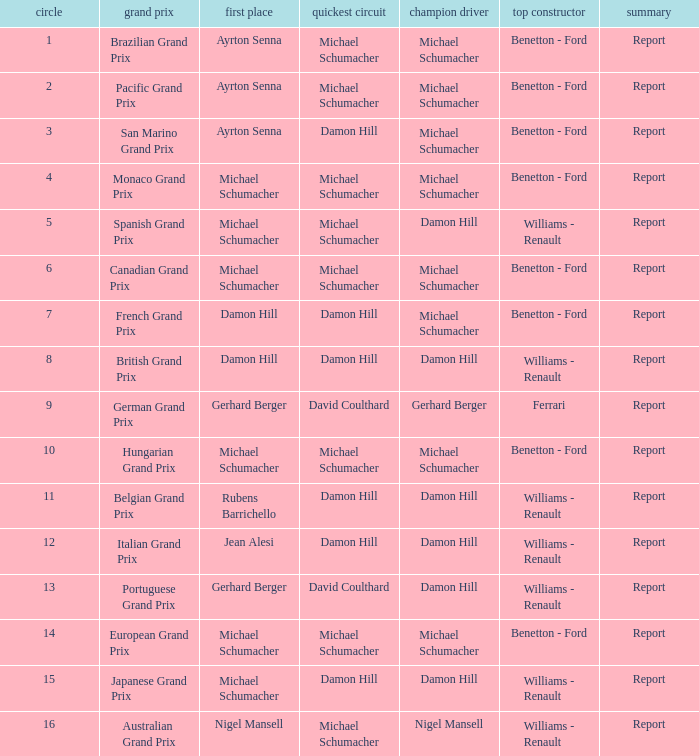Name the fastest lap for the brazilian grand prix Michael Schumacher. 